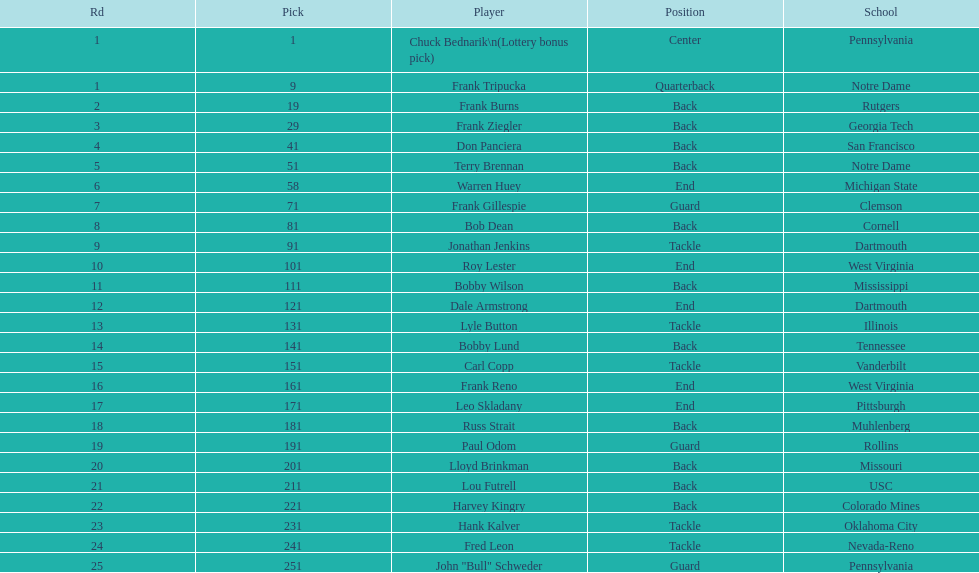How many draft choices were there in between the selections of frank tripucka and dale armstrong? 10. 